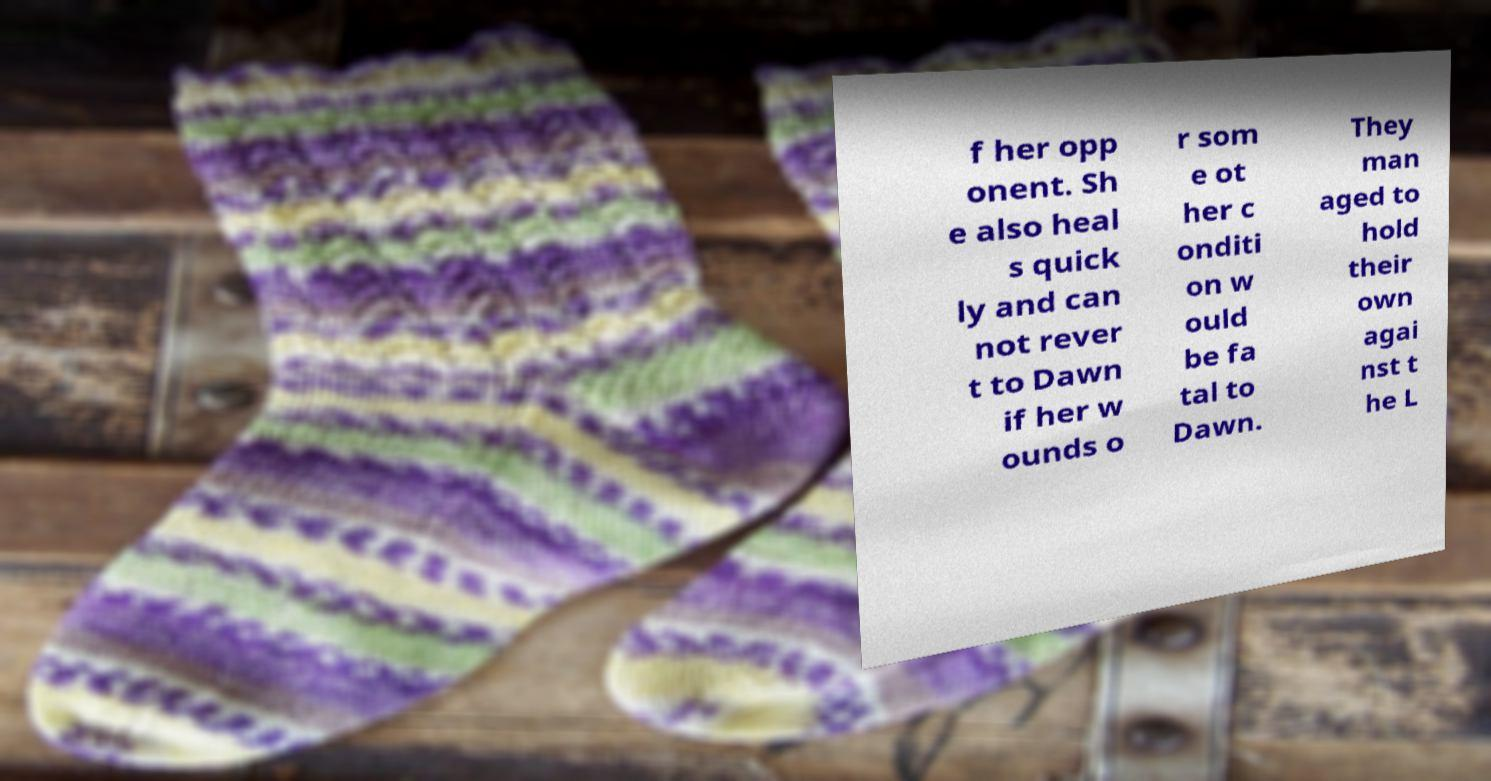Can you accurately transcribe the text from the provided image for me? f her opp onent. Sh e also heal s quick ly and can not rever t to Dawn if her w ounds o r som e ot her c onditi on w ould be fa tal to Dawn. They man aged to hold their own agai nst t he L 